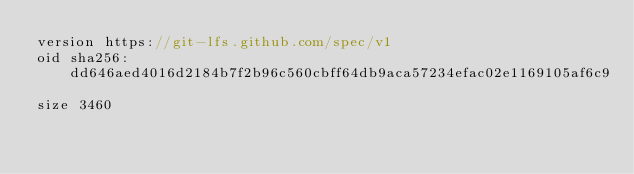Convert code to text. <code><loc_0><loc_0><loc_500><loc_500><_C++_>version https://git-lfs.github.com/spec/v1
oid sha256:dd646aed4016d2184b7f2b96c560cbff64db9aca57234efac02e1169105af6c9
size 3460
</code> 